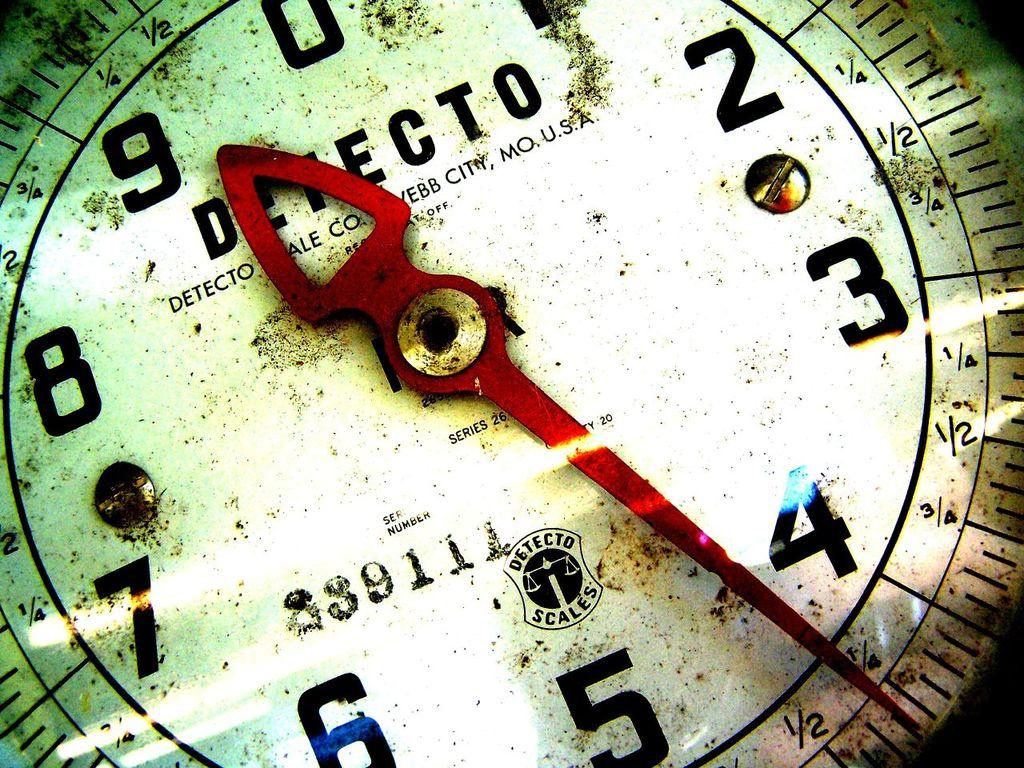<image>
Present a compact description of the photo's key features. A Detecto gauge has the serial number 339111 printed on it. 